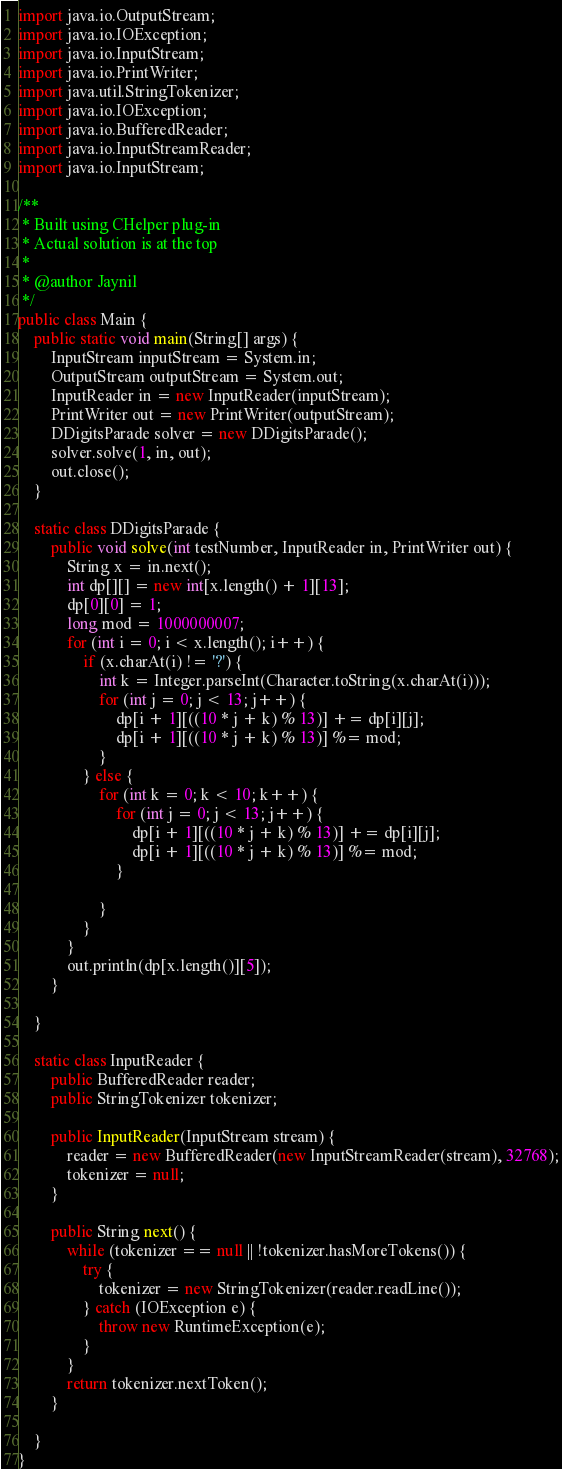Convert code to text. <code><loc_0><loc_0><loc_500><loc_500><_Java_>import java.io.OutputStream;
import java.io.IOException;
import java.io.InputStream;
import java.io.PrintWriter;
import java.util.StringTokenizer;
import java.io.IOException;
import java.io.BufferedReader;
import java.io.InputStreamReader;
import java.io.InputStream;

/**
 * Built using CHelper plug-in
 * Actual solution is at the top
 *
 * @author Jaynil
 */
public class Main {
    public static void main(String[] args) {
        InputStream inputStream = System.in;
        OutputStream outputStream = System.out;
        InputReader in = new InputReader(inputStream);
        PrintWriter out = new PrintWriter(outputStream);
        DDigitsParade solver = new DDigitsParade();
        solver.solve(1, in, out);
        out.close();
    }

    static class DDigitsParade {
        public void solve(int testNumber, InputReader in, PrintWriter out) {
            String x = in.next();
            int dp[][] = new int[x.length() + 1][13];
            dp[0][0] = 1;
            long mod = 1000000007;
            for (int i = 0; i < x.length(); i++) {
                if (x.charAt(i) != '?') {
                    int k = Integer.parseInt(Character.toString(x.charAt(i)));
                    for (int j = 0; j < 13; j++) {
                        dp[i + 1][((10 * j + k) % 13)] += dp[i][j];
                        dp[i + 1][((10 * j + k) % 13)] %= mod;
                    }
                } else {
                    for (int k = 0; k < 10; k++) {
                        for (int j = 0; j < 13; j++) {
                            dp[i + 1][((10 * j + k) % 13)] += dp[i][j];
                            dp[i + 1][((10 * j + k) % 13)] %= mod;
                        }

                    }
                }
            }
            out.println(dp[x.length()][5]);
        }

    }

    static class InputReader {
        public BufferedReader reader;
        public StringTokenizer tokenizer;

        public InputReader(InputStream stream) {
            reader = new BufferedReader(new InputStreamReader(stream), 32768);
            tokenizer = null;
        }

        public String next() {
            while (tokenizer == null || !tokenizer.hasMoreTokens()) {
                try {
                    tokenizer = new StringTokenizer(reader.readLine());
                } catch (IOException e) {
                    throw new RuntimeException(e);
                }
            }
            return tokenizer.nextToken();
        }

    }
}

</code> 